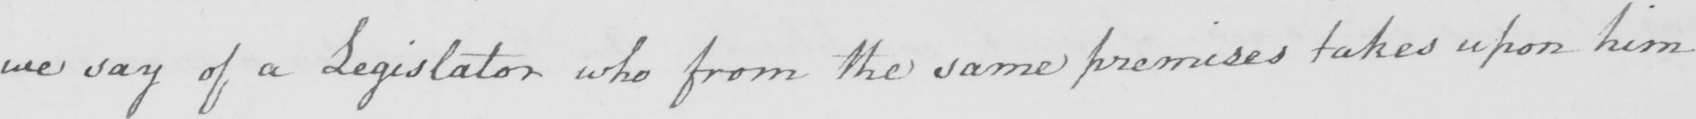What does this handwritten line say? we say of a Legislator who from the same premises takes upon him 